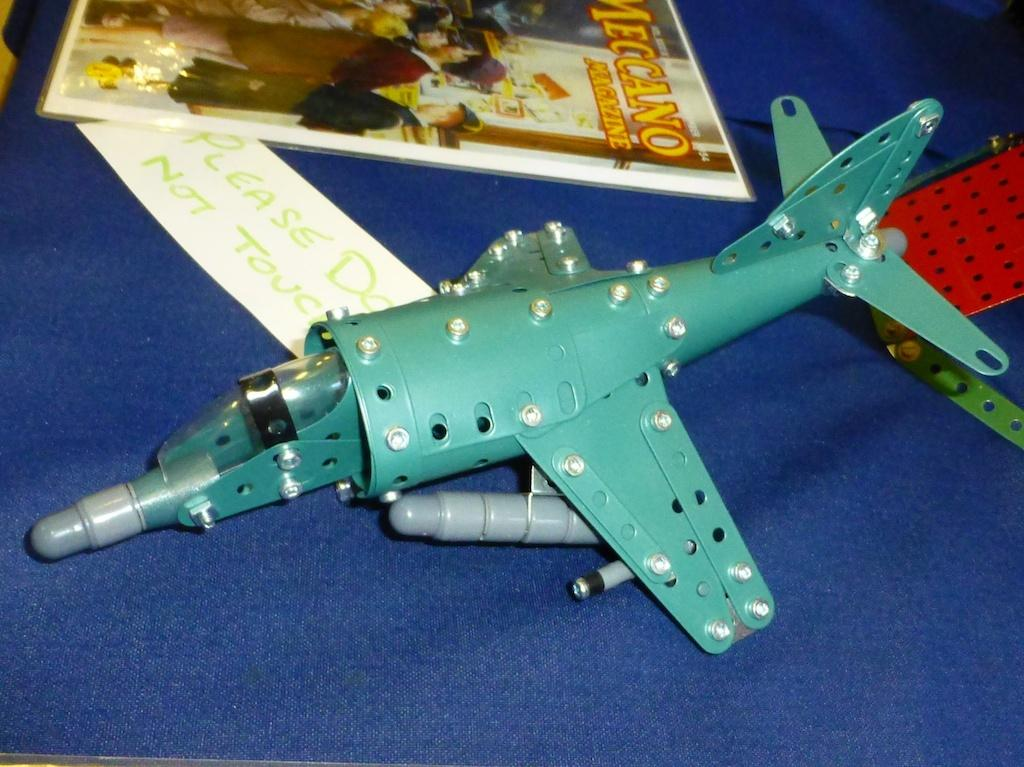<image>
Create a compact narrative representing the image presented. A model airplane is sitting on a table next to an issue of Mecano Magazine. 